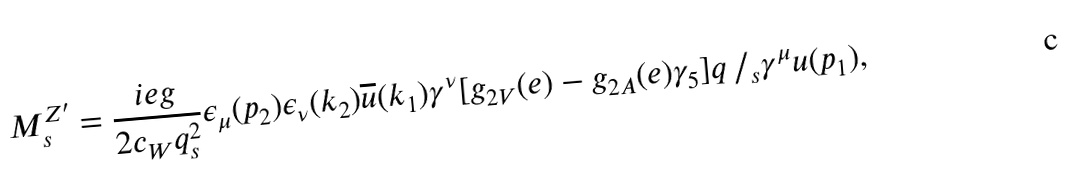<formula> <loc_0><loc_0><loc_500><loc_500>M _ { s } ^ { Z ^ { \prime } } = \frac { i e g } { 2 c _ { W } q ^ { 2 } _ { s } } \epsilon _ { \mu } ( p _ { 2 } ) \epsilon _ { \nu } ( k _ { 2 } ) \overline { u } ( k _ { 1 } ) \gamma ^ { \nu } [ g _ { 2 V } ( e ) - g _ { 2 A } ( e ) \gamma _ { 5 } ] q \, / _ { s } \gamma ^ { \mu } u ( p _ { 1 } ) ,</formula> 